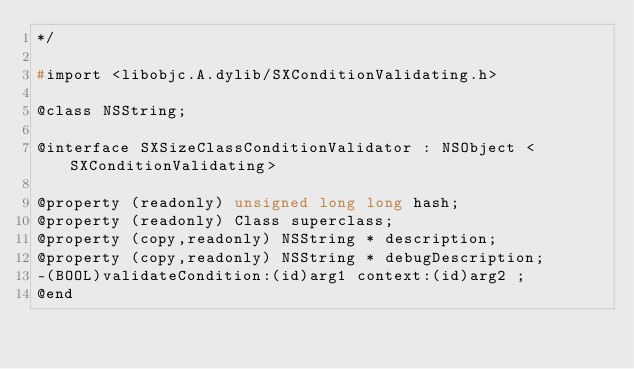<code> <loc_0><loc_0><loc_500><loc_500><_C_>*/

#import <libobjc.A.dylib/SXConditionValidating.h>

@class NSString;

@interface SXSizeClassConditionValidator : NSObject <SXConditionValidating>

@property (readonly) unsigned long long hash; 
@property (readonly) Class superclass; 
@property (copy,readonly) NSString * description; 
@property (copy,readonly) NSString * debugDescription; 
-(BOOL)validateCondition:(id)arg1 context:(id)arg2 ;
@end

</code> 